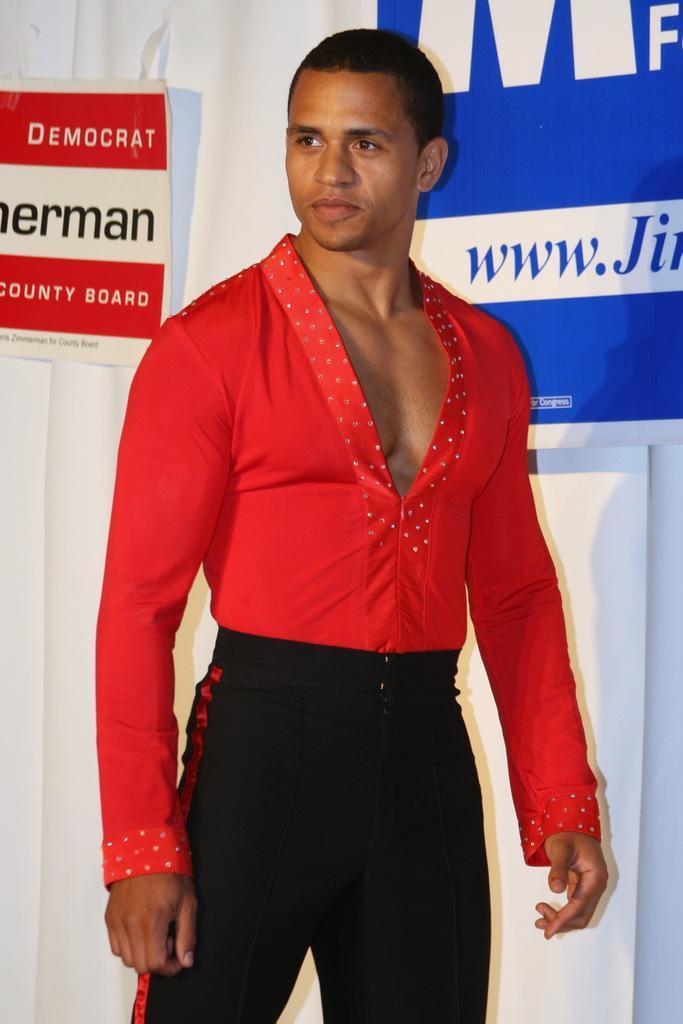Please provide a concise description of this image. In this image we can see a man standing on the floor. In the background there are advertisements attached to the curtain. 